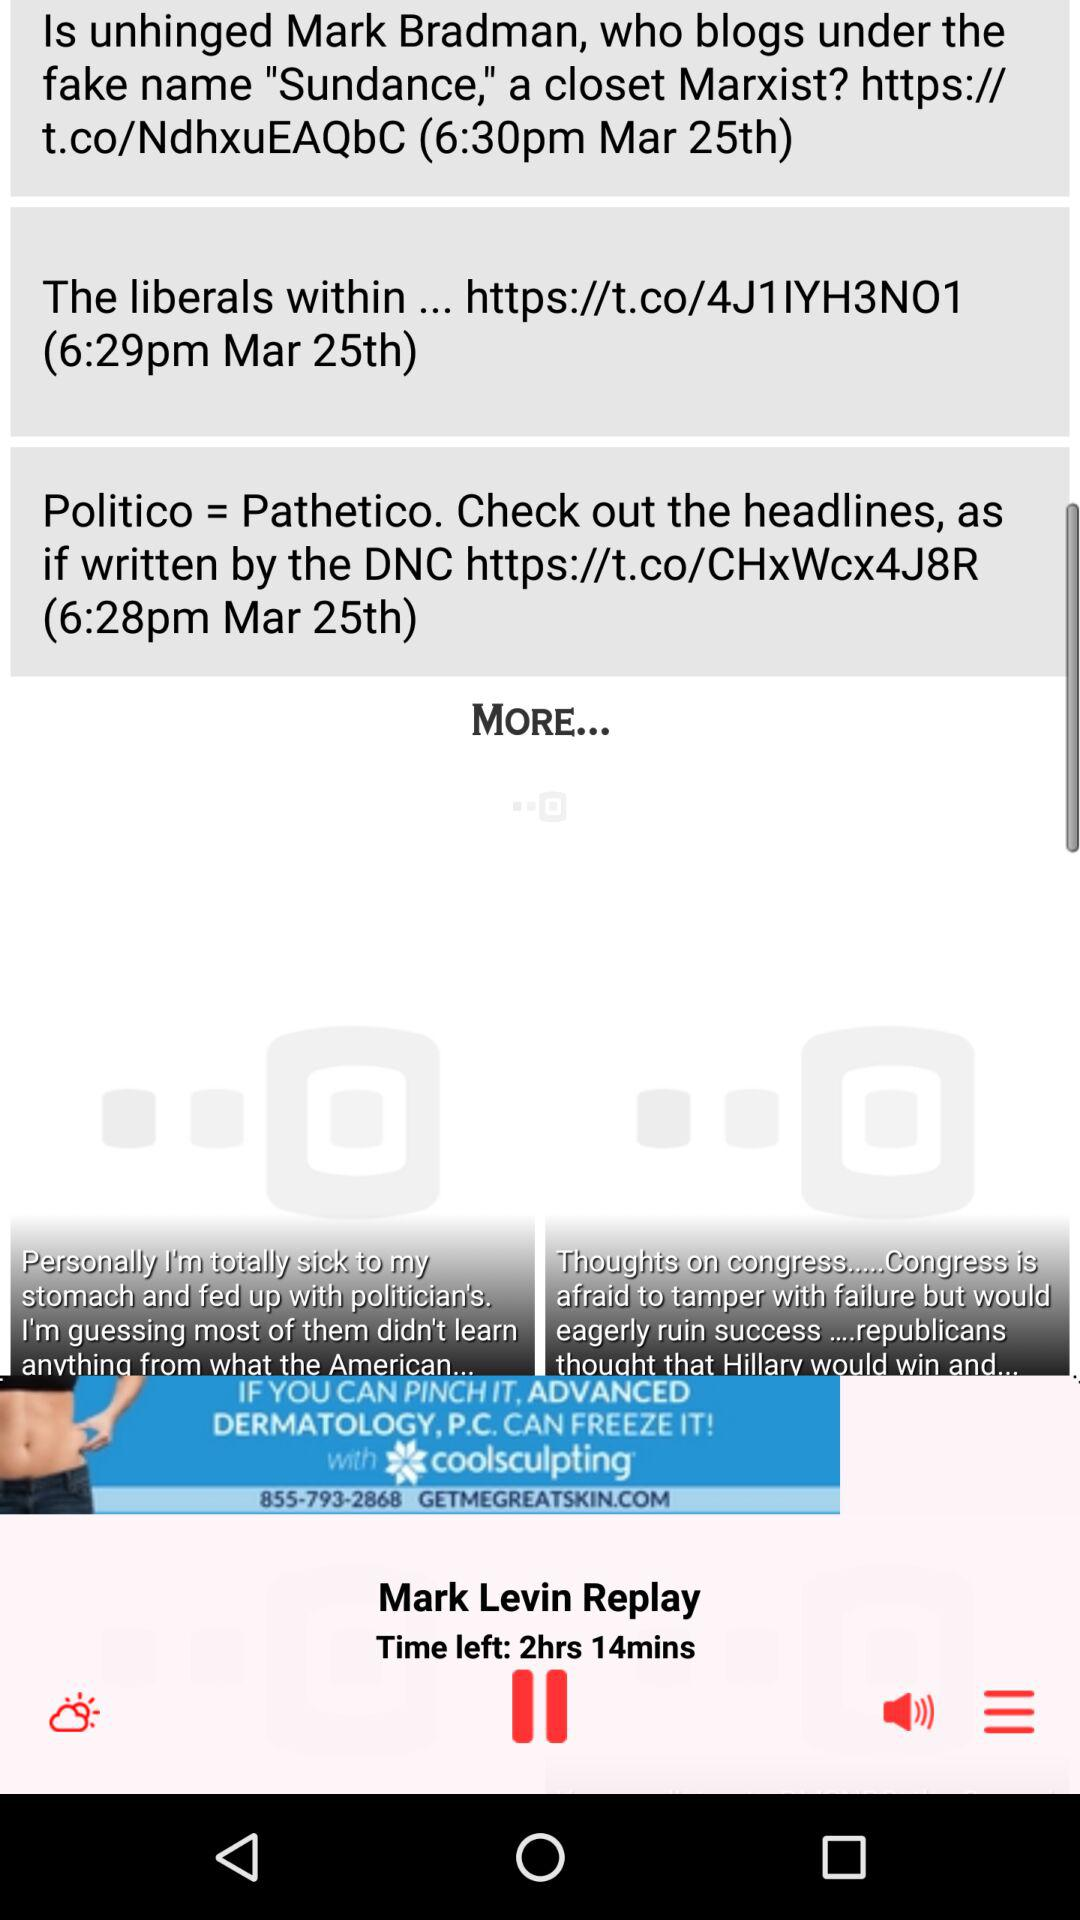What is the date of the news posted at 6:30 pm? The date of the news is March 25. 